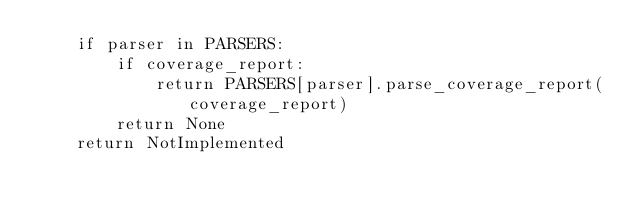<code> <loc_0><loc_0><loc_500><loc_500><_Python_>    if parser in PARSERS:
        if coverage_report:
            return PARSERS[parser].parse_coverage_report(coverage_report)
        return None
    return NotImplemented
</code> 